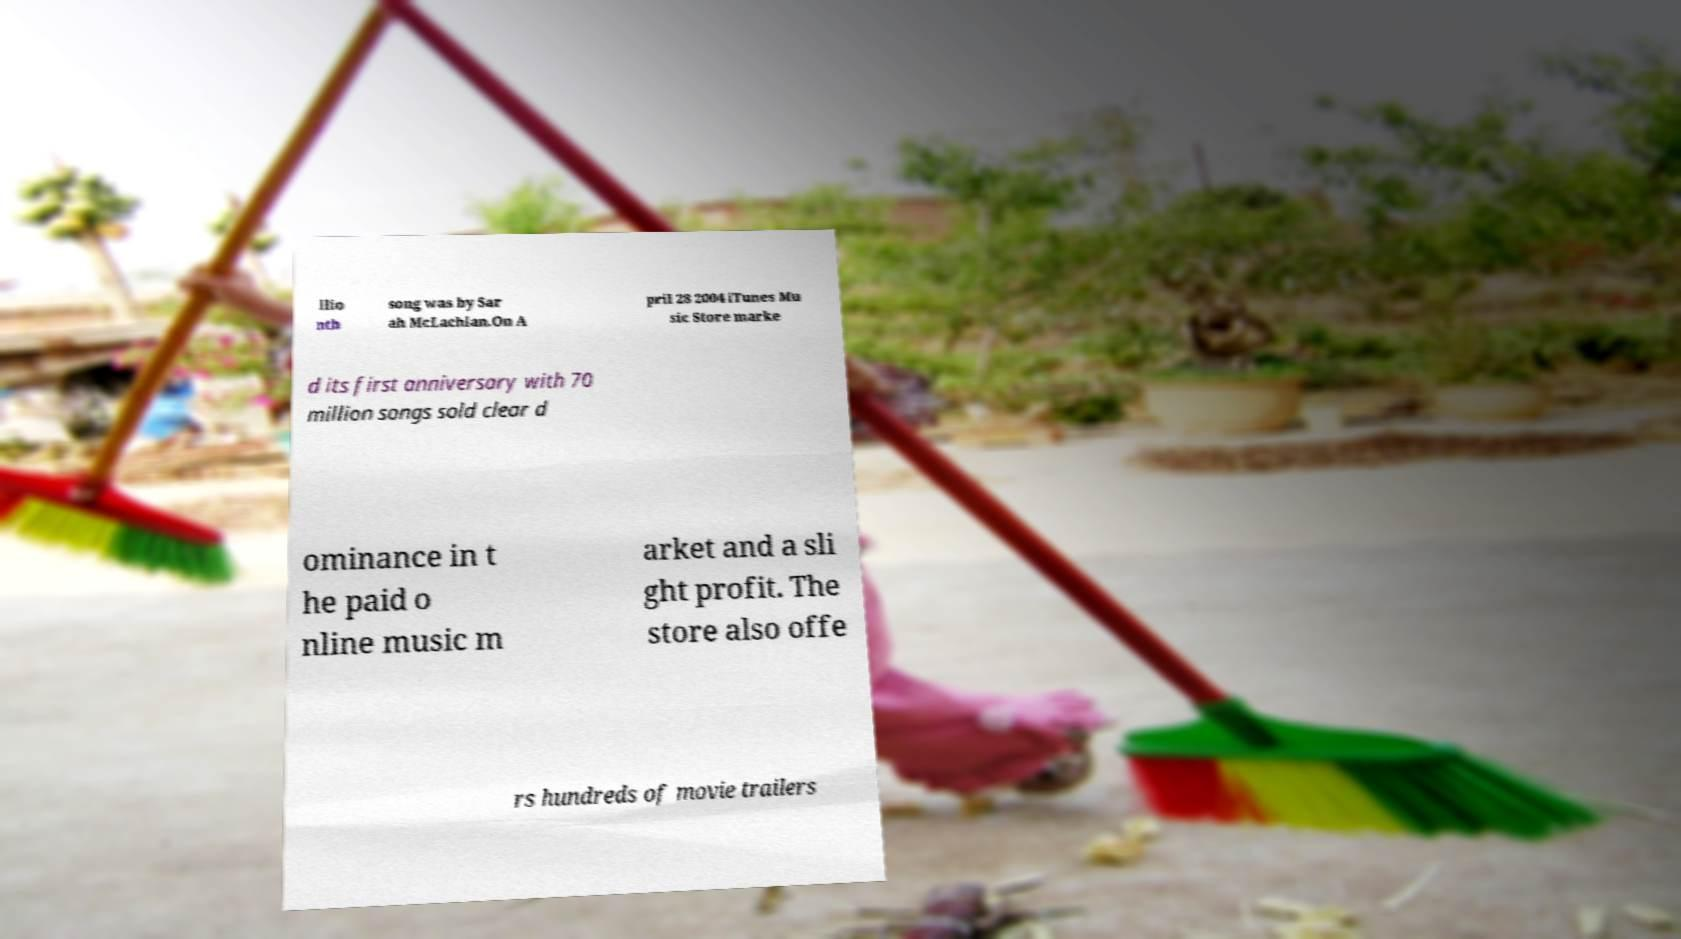For documentation purposes, I need the text within this image transcribed. Could you provide that? llio nth song was by Sar ah McLachlan.On A pril 28 2004 iTunes Mu sic Store marke d its first anniversary with 70 million songs sold clear d ominance in t he paid o nline music m arket and a sli ght profit. The store also offe rs hundreds of movie trailers 